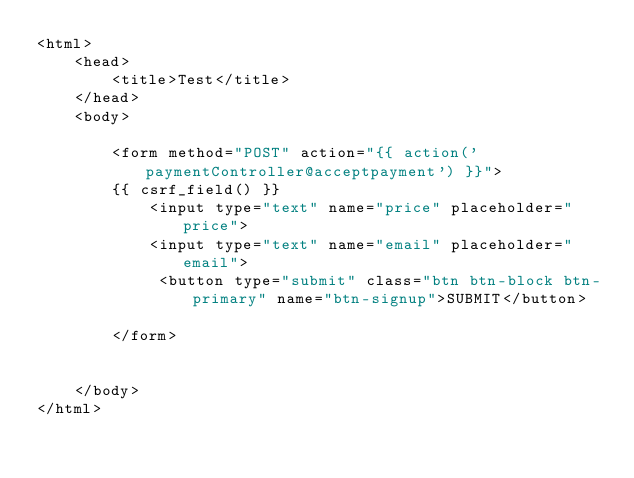Convert code to text. <code><loc_0><loc_0><loc_500><loc_500><_PHP_><html>
    <head>
        <title>Test</title>
    </head>
    <body>

        <form method="POST" action="{{ action('paymentController@acceptpayment') }}">
        {{ csrf_field() }}
            <input type="text" name="price" placeholder="price">
            <input type="text" name="email" placeholder="email">
             <button type="submit" class="btn btn-block btn-primary" name="btn-signup">SUBMIT</button>

        </form>


    </body>
</html></code> 